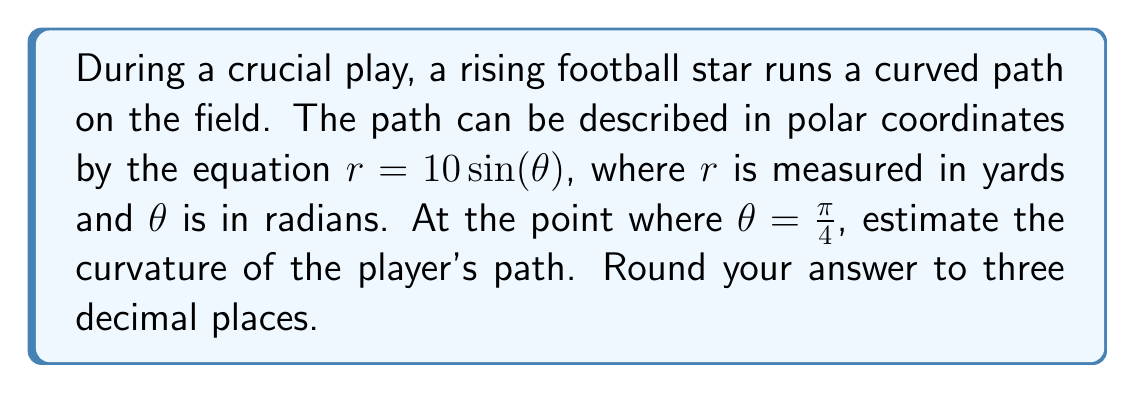Can you solve this math problem? To solve this problem, we'll follow these steps:

1) The curvature $\kappa$ of a polar curve is given by the formula:

   $$\kappa = \frac{|r^2 + 2(r')^2 - rr''|}{(r^2 + (r')^2)^{3/2}}$$

   where $r'$ and $r''$ are the first and second derivatives of $r$ with respect to $\theta$.

2) Given equation: $r = 10\sin(\theta)$

3) Calculate $r'$:
   $$r' = 10\cos(\theta)$$

4) Calculate $r''$:
   $$r'' = -10\sin(\theta)$$

5) At $\theta = \frac{\pi}{4}$:
   
   $r = 10\sin(\frac{\pi}{4}) = 10 \cdot \frac{\sqrt{2}}{2} = 5\sqrt{2}$
   
   $r' = 10\cos(\frac{\pi}{4}) = 10 \cdot \frac{\sqrt{2}}{2} = 5\sqrt{2}$
   
   $r'' = -10\sin(\frac{\pi}{4}) = -10 \cdot \frac{\sqrt{2}}{2} = -5\sqrt{2}$

6) Substitute these values into the curvature formula:

   $$\kappa = \frac{|(5\sqrt{2})^2 + 2(5\sqrt{2})^2 - (5\sqrt{2})(-5\sqrt{2})|}{((5\sqrt{2})^2 + (5\sqrt{2})^2)^{3/2}}$$

7) Simplify:
   $$\kappa = \frac{|50 + 100 + 50|}{(50 + 50)^{3/2}} = \frac{200}{100^{3/2}} = \frac{2}{10\sqrt{10}} \approx 0.063$$

8) Rounding to three decimal places: 0.063
Answer: The curvature of the player's path at $\theta = \frac{\pi}{4}$ is approximately 0.063 yards^(-1). 